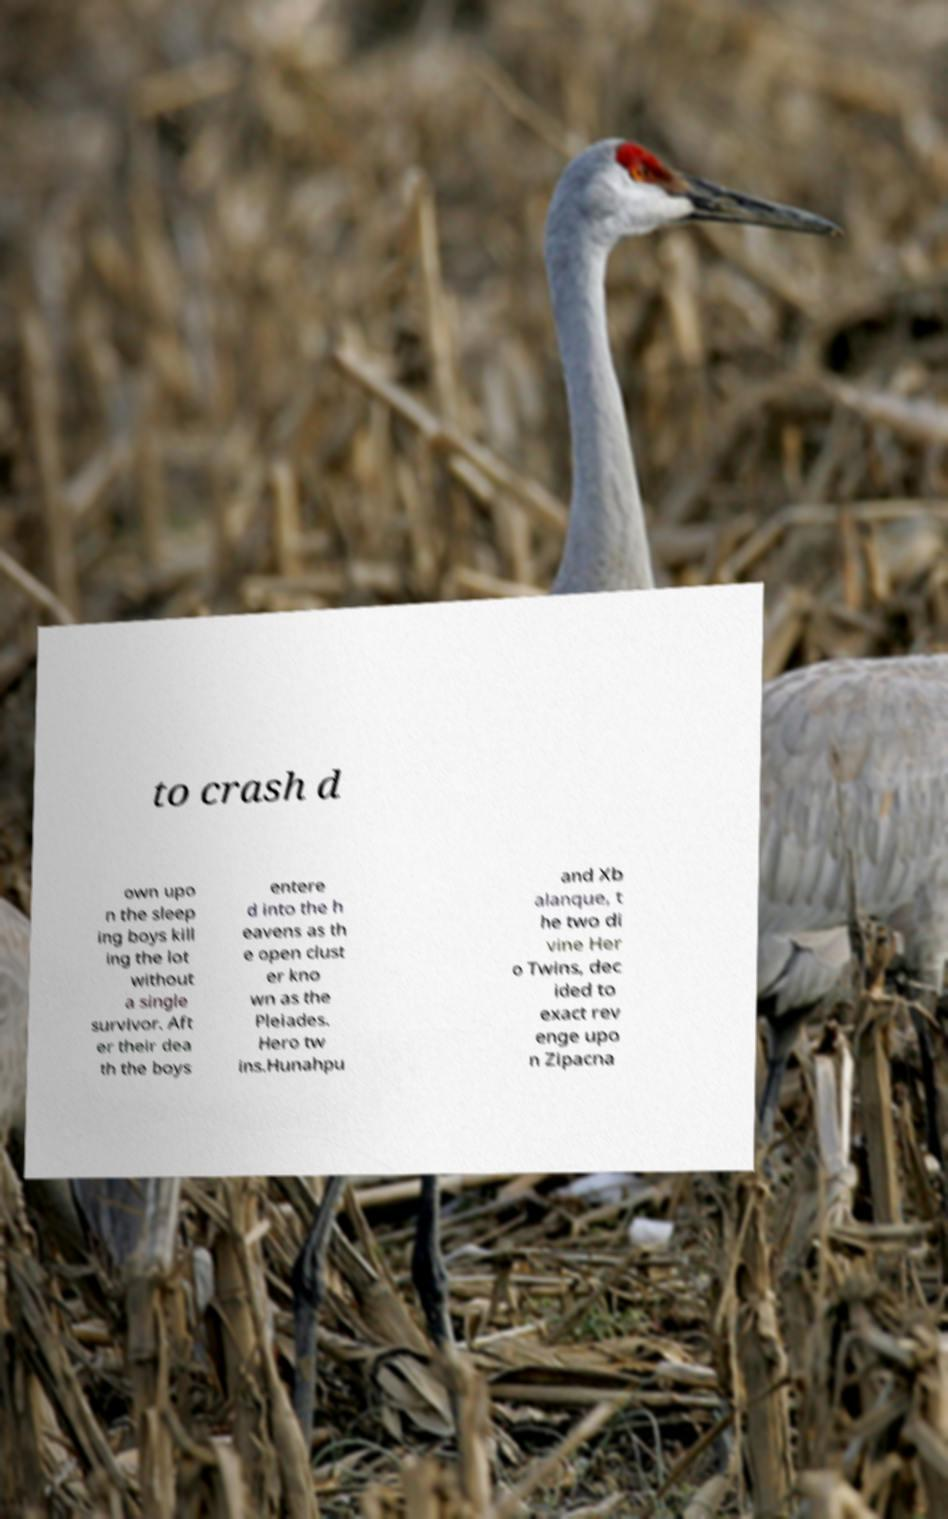Can you read and provide the text displayed in the image?This photo seems to have some interesting text. Can you extract and type it out for me? to crash d own upo n the sleep ing boys kill ing the lot without a single survivor. Aft er their dea th the boys entere d into the h eavens as th e open clust er kno wn as the Pleiades. Hero tw ins.Hunahpu and Xb alanque, t he two di vine Her o Twins, dec ided to exact rev enge upo n Zipacna 